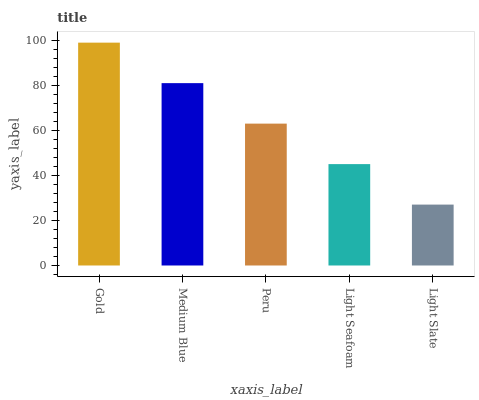Is Light Slate the minimum?
Answer yes or no. Yes. Is Gold the maximum?
Answer yes or no. Yes. Is Medium Blue the minimum?
Answer yes or no. No. Is Medium Blue the maximum?
Answer yes or no. No. Is Gold greater than Medium Blue?
Answer yes or no. Yes. Is Medium Blue less than Gold?
Answer yes or no. Yes. Is Medium Blue greater than Gold?
Answer yes or no. No. Is Gold less than Medium Blue?
Answer yes or no. No. Is Peru the high median?
Answer yes or no. Yes. Is Peru the low median?
Answer yes or no. Yes. Is Medium Blue the high median?
Answer yes or no. No. Is Light Slate the low median?
Answer yes or no. No. 